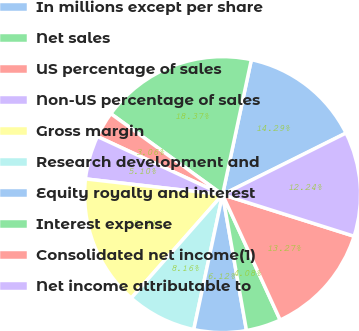Convert chart to OTSL. <chart><loc_0><loc_0><loc_500><loc_500><pie_chart><fcel>In millions except per share<fcel>Net sales<fcel>US percentage of sales<fcel>Non-US percentage of sales<fcel>Gross margin<fcel>Research development and<fcel>Equity royalty and interest<fcel>Interest expense<fcel>Consolidated net income(1)<fcel>Net income attributable to<nl><fcel>14.29%<fcel>18.37%<fcel>3.06%<fcel>5.1%<fcel>15.31%<fcel>8.16%<fcel>6.12%<fcel>4.08%<fcel>13.27%<fcel>12.24%<nl></chart> 